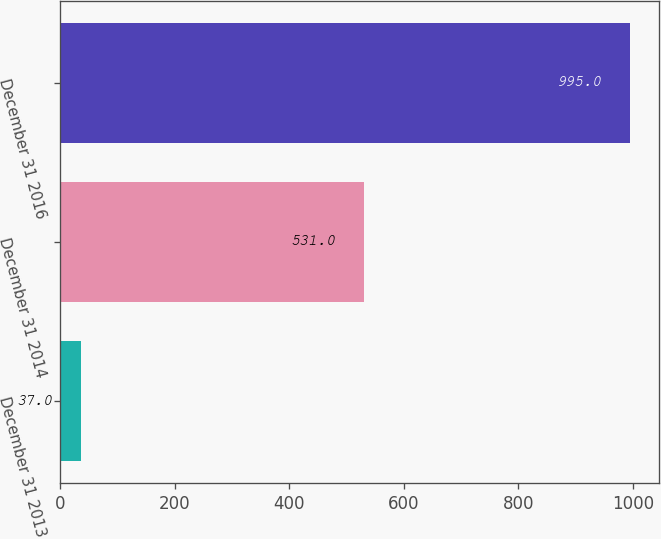Convert chart. <chart><loc_0><loc_0><loc_500><loc_500><bar_chart><fcel>December 31 2013<fcel>December 31 2014<fcel>December 31 2016<nl><fcel>37<fcel>531<fcel>995<nl></chart> 